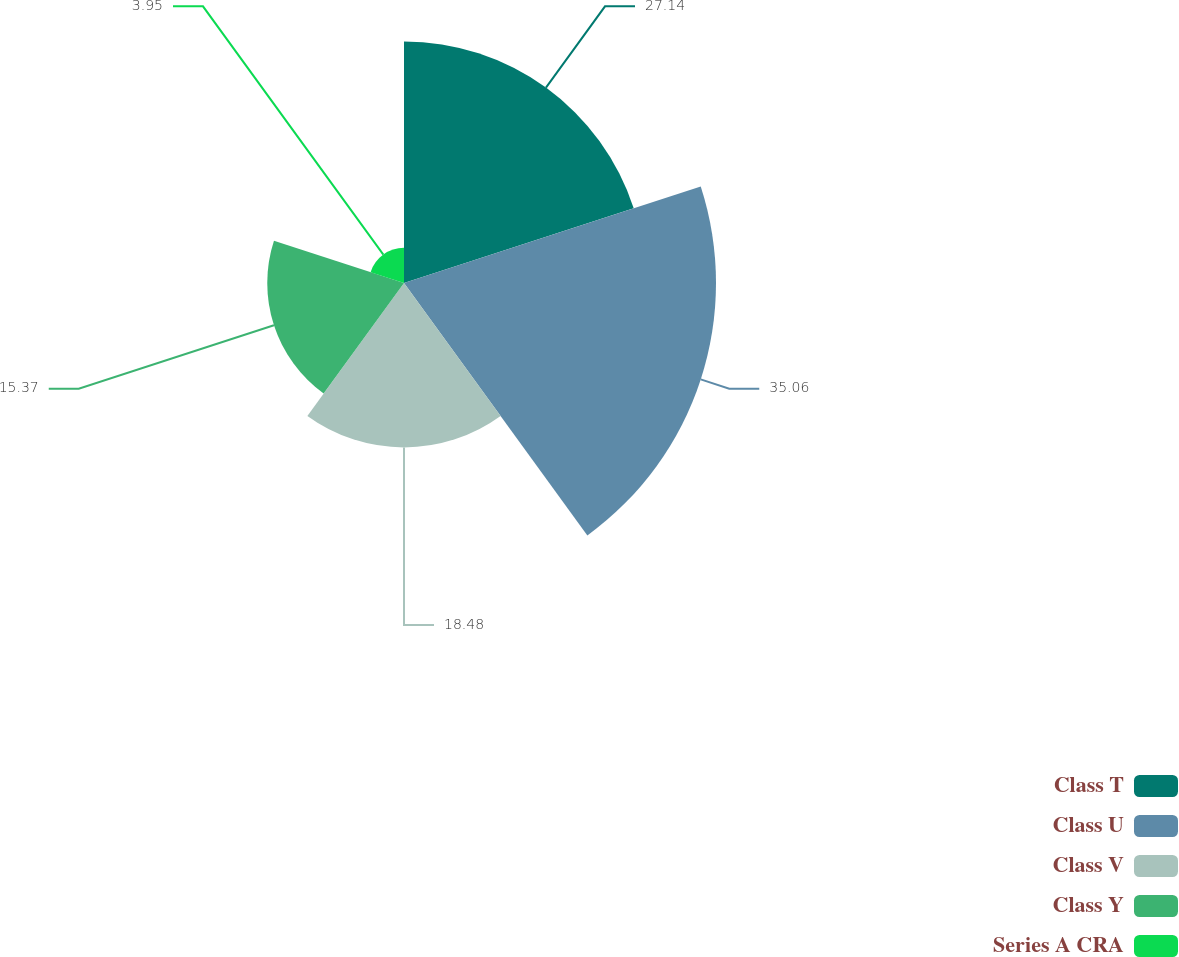Convert chart. <chart><loc_0><loc_0><loc_500><loc_500><pie_chart><fcel>Class T<fcel>Class U<fcel>Class V<fcel>Class Y<fcel>Series A CRA<nl><fcel>27.15%<fcel>35.07%<fcel>18.48%<fcel>15.37%<fcel>3.95%<nl></chart> 